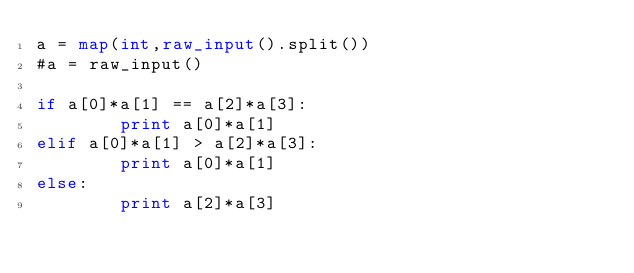Convert code to text. <code><loc_0><loc_0><loc_500><loc_500><_Python_>a = map(int,raw_input().split())
#a = raw_input()

if a[0]*a[1] == a[2]*a[3]:
        print a[0]*a[1]
elif a[0]*a[1] > a[2]*a[3]:
        print a[0]*a[1]
else:
        print a[2]*a[3]</code> 